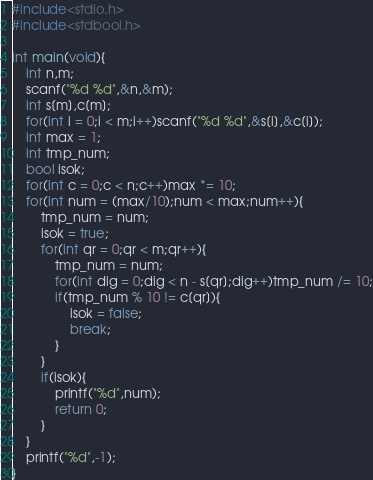<code> <loc_0><loc_0><loc_500><loc_500><_C_>#include<stdio.h>
#include<stdbool.h>

int main(void){
    int n,m;
    scanf("%d %d",&n,&m);
    int s[m],c[m];
    for(int i = 0;i < m;i++)scanf("%d %d",&s[i],&c[i]);
    int max = 1;
    int tmp_num;
    bool isok;
    for(int c = 0;c < n;c++)max *= 10;
    for(int num = (max/10);num < max;num++){
        tmp_num = num;
        isok = true;
        for(int qr = 0;qr < m;qr++){
            tmp_num = num;
            for(int dig = 0;dig < n - s[qr];dig++)tmp_num /= 10;
            if(tmp_num % 10 != c[qr]){
                isok = false;
                break;
            }
        }
        if(isok){
            printf("%d",num);
            return 0;
        }
    }
    printf("%d",-1);
}</code> 